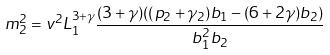<formula> <loc_0><loc_0><loc_500><loc_500>m ^ { 2 } _ { 2 } = v ^ { 2 } L ^ { 3 + \gamma } _ { 1 } \frac { ( 3 + \gamma ) ( ( p _ { 2 } + \gamma _ { 2 } ) b _ { 1 } - ( 6 + 2 \gamma ) b _ { 2 } ) } { b ^ { 2 } _ { 1 } b _ { 2 } }</formula> 